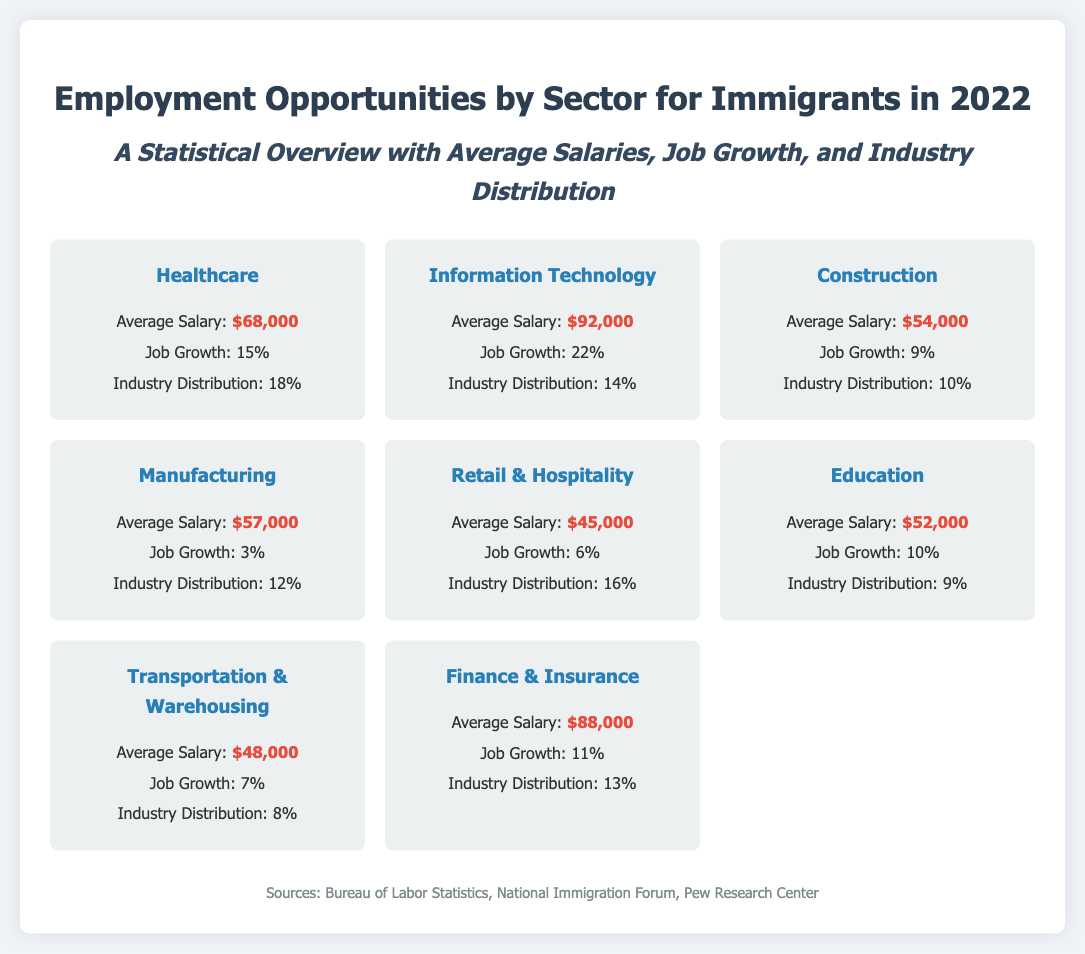what is the average salary in Healthcare? The average salary for the Healthcare sector is explicitly stated in the document.
Answer: $68,000 which sector has the highest job growth? The document lists job growth percentages for each sector, indicating which has the highest rate.
Answer: Information Technology what percentage of industry distribution does Retail & Hospitality represent? The document provides specific percentages for the industry distribution across sectors.
Answer: 16% what is the average salary for the Manufacturing sector? The average salary for Manufacturing is mentioned in the document as part of the sector's information.
Answer: $57,000 which sector has the lowest job growth? By comparing the job growth percentages across all sectors, we can identify the sector with the lowest growth rate.
Answer: Manufacturing what is the industry distribution percentage for Education? The document explicitly gives the industry distribution percentage for the Education sector.
Answer: 9% which sector has an average salary closest to $50,000? Analyzing the average salaries in the document, we can determine which sector's salary is closest to that figure.
Answer: Transportation & Warehousing what is the average salary in Information Technology? The average salary for Information Technology is specifically mentioned in the document.
Answer: $92,000 